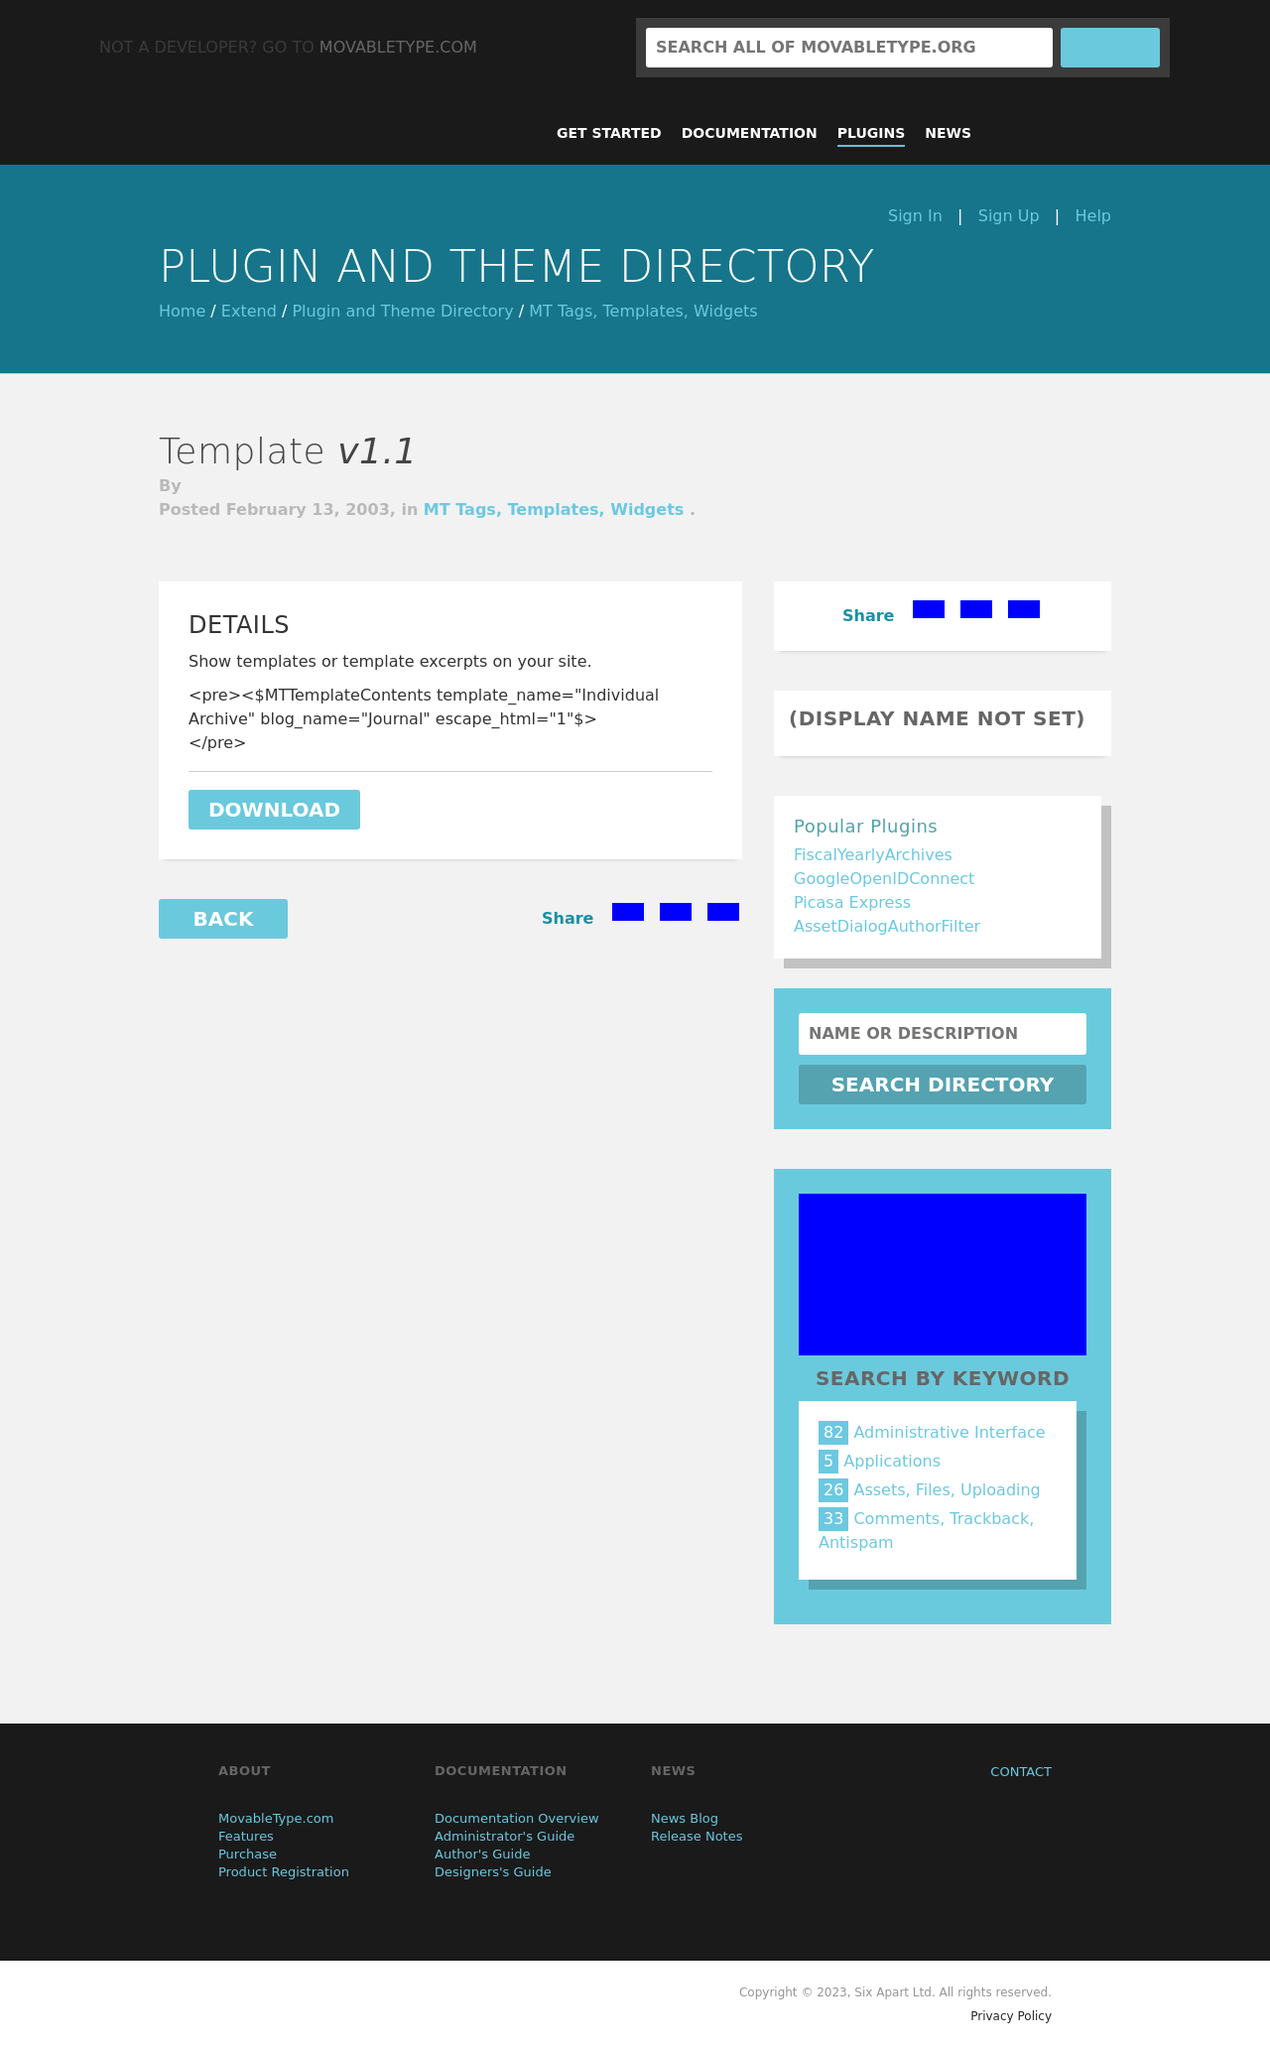How can I start building this website with HTML from the ground up? To start building a website with HTML, begin by creating a fundamental HTML document structure with tags like <html>, <head>, <title>, and <body>. Inside the <body>, add structural elements such as <header>, <nav>, <main>, and <footer> to define sections. Use <h1> to <h6> for headings, <p> for paragraphs, <a> for links, and <img> for images. After you have your HTML structure, you can style it with CSS and make it interactive with JavaScript. 